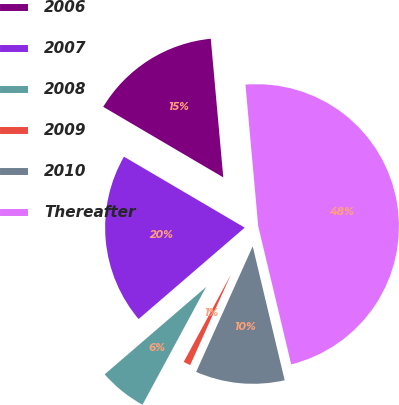Convert chart. <chart><loc_0><loc_0><loc_500><loc_500><pie_chart><fcel>2006<fcel>2007<fcel>2008<fcel>2009<fcel>2010<fcel>Thereafter<nl><fcel>15.11%<fcel>19.77%<fcel>5.8%<fcel>1.15%<fcel>10.46%<fcel>47.7%<nl></chart> 